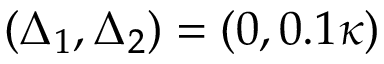<formula> <loc_0><loc_0><loc_500><loc_500>( \Delta _ { 1 } , \Delta _ { 2 } ) = ( 0 , 0 . 1 \kappa )</formula> 